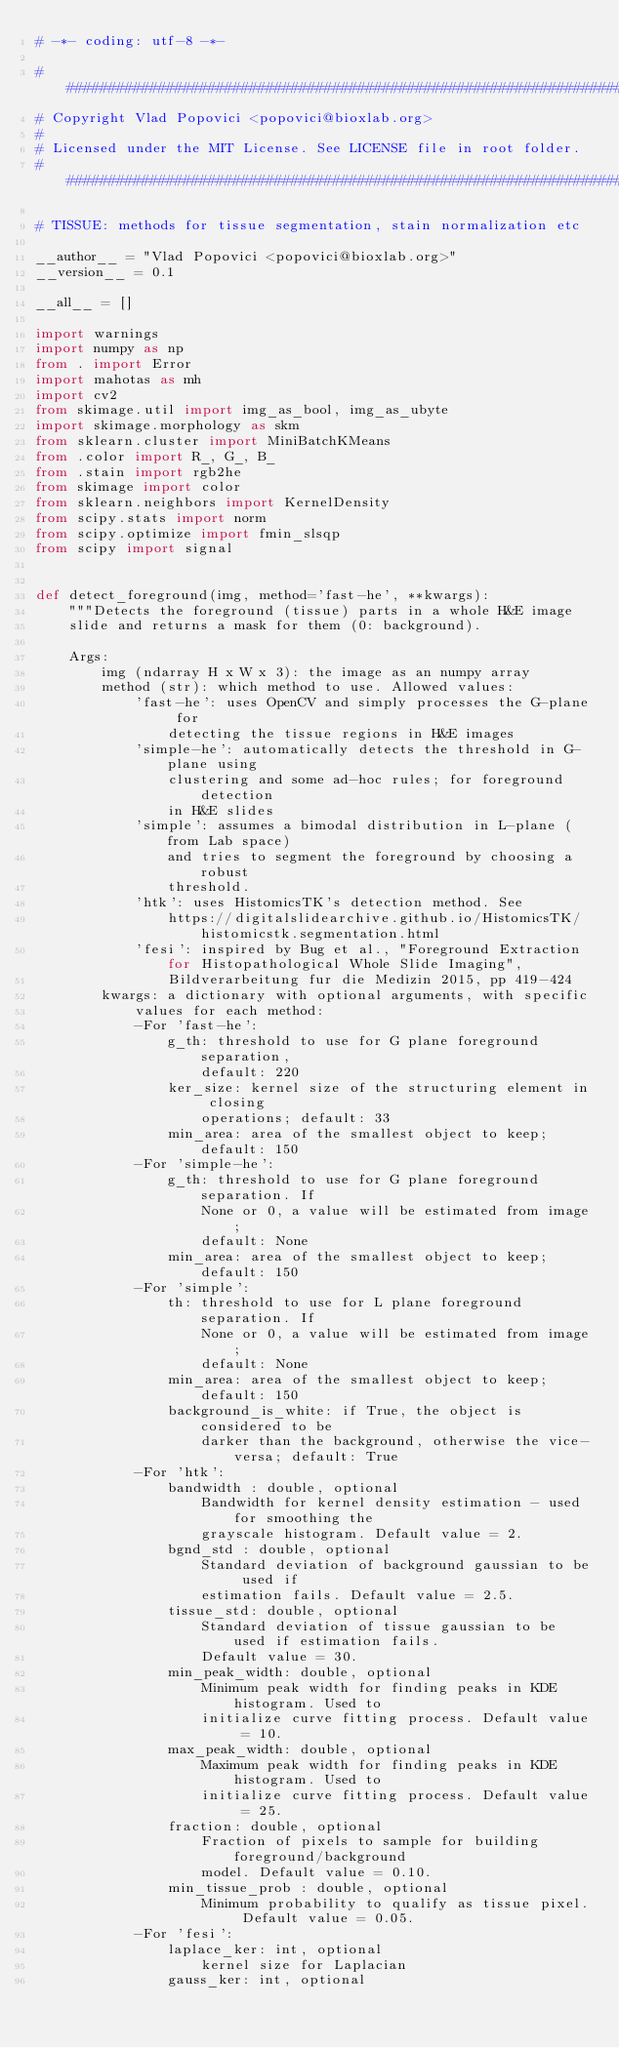Convert code to text. <code><loc_0><loc_0><loc_500><loc_500><_Python_># -*- coding: utf-8 -*-

#############################################################################
# Copyright Vlad Popovici <popovici@bioxlab.org>
#
# Licensed under the MIT License. See LICENSE file in root folder.
#############################################################################

# TISSUE: methods for tissue segmentation, stain normalization etc

__author__ = "Vlad Popovici <popovici@bioxlab.org>"
__version__ = 0.1

__all__ = []

import warnings
import numpy as np
from . import Error
import mahotas as mh
import cv2
from skimage.util import img_as_bool, img_as_ubyte
import skimage.morphology as skm
from sklearn.cluster import MiniBatchKMeans
from .color import R_, G_, B_
from .stain import rgb2he
from skimage import color
from sklearn.neighbors import KernelDensity
from scipy.stats import norm
from scipy.optimize import fmin_slsqp
from scipy import signal


def detect_foreground(img, method='fast-he', **kwargs):
    """Detects the foreground (tissue) parts in a whole H&E image
    slide and returns a mask for them (0: background).

    Args:
        img (ndarray H x W x 3): the image as an numpy array
        method (str): which method to use. Allowed values:
            'fast-he': uses OpenCV and simply processes the G-plane for
                detecting the tissue regions in H&E images
            'simple-he': automatically detects the threshold in G-plane using
                clustering and some ad-hoc rules; for foreground detection
                in H&E slides
            'simple': assumes a bimodal distribution in L-plane (from Lab space)
                and tries to segment the foreground by choosing a robust
                threshold.
            'htk': uses HistomicsTK's detection method. See
                https://digitalslidearchive.github.io/HistomicsTK/histomicstk.segmentation.html
            'fesi': inspired by Bug et al., "Foreground Extraction for Histopathological Whole Slide Imaging",
                Bildverarbeitung fur die Medizin 2015, pp 419-424
        kwargs: a dictionary with optional arguments, with specific
            values for each method:
            -For 'fast-he':
                g_th: threshold to use for G plane foreground separation,
                    default: 220
                ker_size: kernel size of the structuring element in closing
                    operations; default: 33
                min_area: area of the smallest object to keep; default: 150
            -For 'simple-he':
                g_th: threshold to use for G plane foreground separation. If
                    None or 0, a value will be estimated from image;
                    default: None
                min_area: area of the smallest object to keep; default: 150
            -For 'simple':
                th: threshold to use for L plane foreground separation. If
                    None or 0, a value will be estimated from image;
                    default: None
                min_area: area of the smallest object to keep; default: 150
                background_is_white: if True, the object is considered to be
                    darker than the background, otherwise the vice-versa; default: True
            -For 'htk':
                bandwidth : double, optional
                    Bandwidth for kernel density estimation - used for smoothing the
                    grayscale histogram. Default value = 2.
                bgnd_std : double, optional
                    Standard deviation of background gaussian to be used if
                    estimation fails. Default value = 2.5.
                tissue_std: double, optional
                    Standard deviation of tissue gaussian to be used if estimation fails.
                    Default value = 30.
                min_peak_width: double, optional
                    Minimum peak width for finding peaks in KDE histogram. Used to
                    initialize curve fitting process. Default value = 10.
                max_peak_width: double, optional
                    Maximum peak width for finding peaks in KDE histogram. Used to
                    initialize curve fitting process. Default value = 25.
                fraction: double, optional
                    Fraction of pixels to sample for building foreground/background
                    model. Default value = 0.10.
                min_tissue_prob : double, optional
                    Minimum probability to qualify as tissue pixel. Default value = 0.05.
            -For 'fesi':
                laplace_ker: int, optional
                    kernel size for Laplacian
                gauss_ker: int, optional</code> 